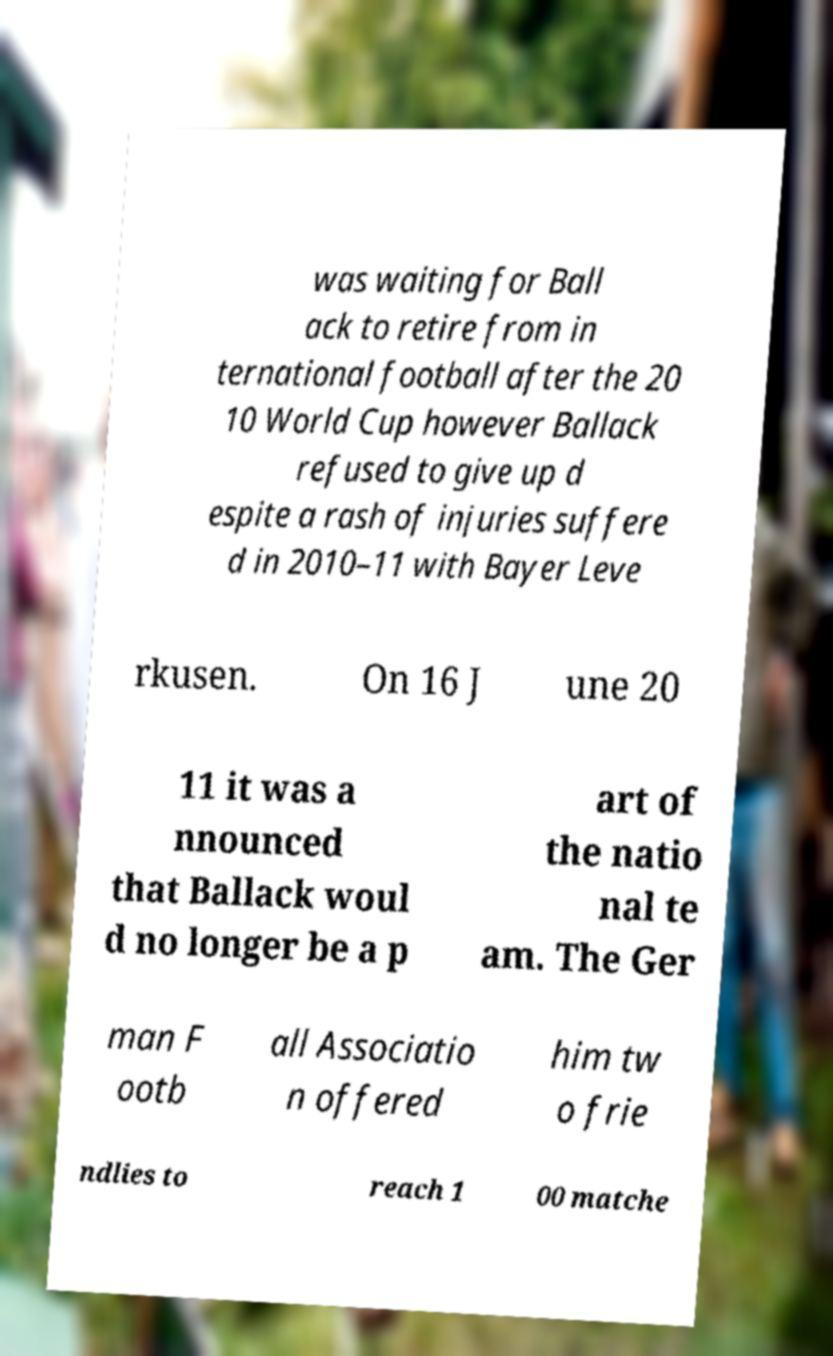Please identify and transcribe the text found in this image. was waiting for Ball ack to retire from in ternational football after the 20 10 World Cup however Ballack refused to give up d espite a rash of injuries suffere d in 2010–11 with Bayer Leve rkusen. On 16 J une 20 11 it was a nnounced that Ballack woul d no longer be a p art of the natio nal te am. The Ger man F ootb all Associatio n offered him tw o frie ndlies to reach 1 00 matche 